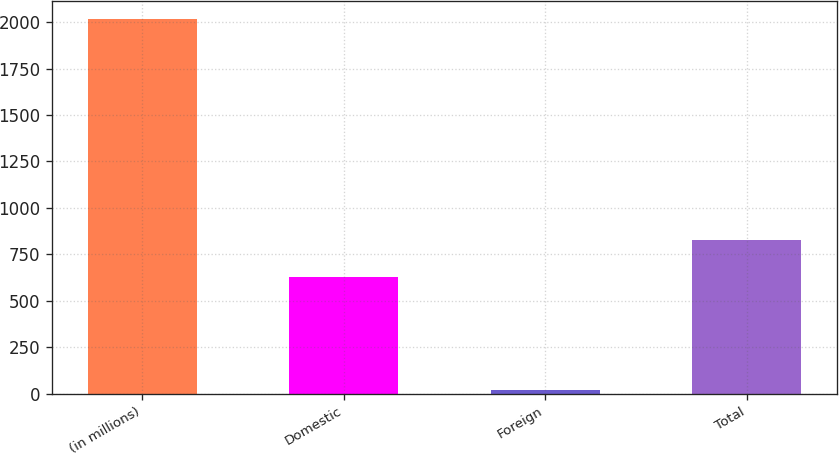<chart> <loc_0><loc_0><loc_500><loc_500><bar_chart><fcel>(in millions)<fcel>Domestic<fcel>Foreign<fcel>Total<nl><fcel>2015<fcel>626.4<fcel>20.6<fcel>825.84<nl></chart> 